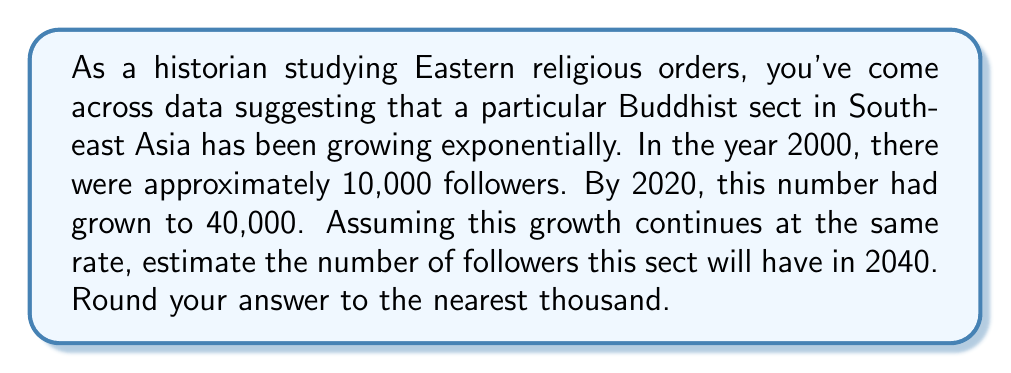Could you help me with this problem? To solve this problem, we'll use the exponential growth model:

$$A = P(1 + r)^t$$

Where:
$A$ = Final amount
$P$ = Initial amount (principal)
$r$ = Growth rate (in decimal form)
$t$ = Time period

We know:
$P = 10,000$ (initial population in 2000)
$A = 40,000$ (population in 2020)
$t = 20$ years (from 2000 to 2020)

Let's find the growth rate $r$:

$$40,000 = 10,000(1 + r)^{20}$$

$$4 = (1 + r)^{20}$$

$$\sqrt[20]{4} = 1 + r$$

$$r = \sqrt[20]{4} - 1 \approx 0.0717 \text{ or } 7.17\% \text{ per year}$$

Now that we have the growth rate, we can estimate the population in 2040:

$$A = 40,000(1 + 0.0717)^{20}$$

Using a calculator:

$$A \approx 160,474$$

Rounding to the nearest thousand:

$$A \approx 160,000$$
Answer: Approximately 160,000 followers in 2040. 